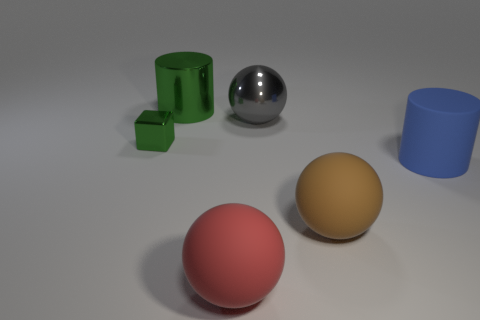Are there any other things that have the same size as the cube?
Provide a succinct answer. No. What number of other things are the same color as the tiny block?
Provide a short and direct response. 1. What is the material of the green object in front of the green object that is on the right side of the small thing?
Ensure brevity in your answer.  Metal. There is a ball that is in front of the blue object and behind the red rubber object; what material is it?
Ensure brevity in your answer.  Rubber. Is there a shiny object of the same shape as the large red rubber object?
Offer a terse response. Yes. Are there any brown rubber balls that are behind the blue matte thing that is to the right of the large brown ball?
Give a very brief answer. No. What number of small brown objects are the same material as the big brown ball?
Make the answer very short. 0. Are there any rubber things?
Provide a short and direct response. Yes. How many cylinders are the same color as the metal cube?
Make the answer very short. 1. Is the material of the large brown object the same as the cylinder that is right of the big red rubber sphere?
Offer a very short reply. Yes. 